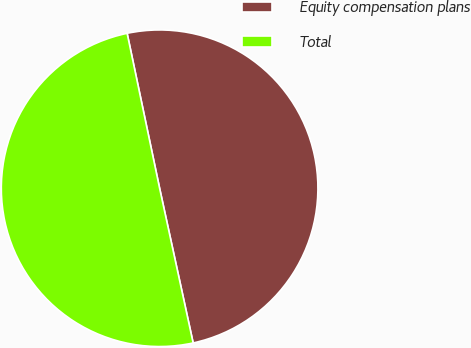<chart> <loc_0><loc_0><loc_500><loc_500><pie_chart><fcel>Equity compensation plans<fcel>Total<nl><fcel>49.89%<fcel>50.11%<nl></chart> 